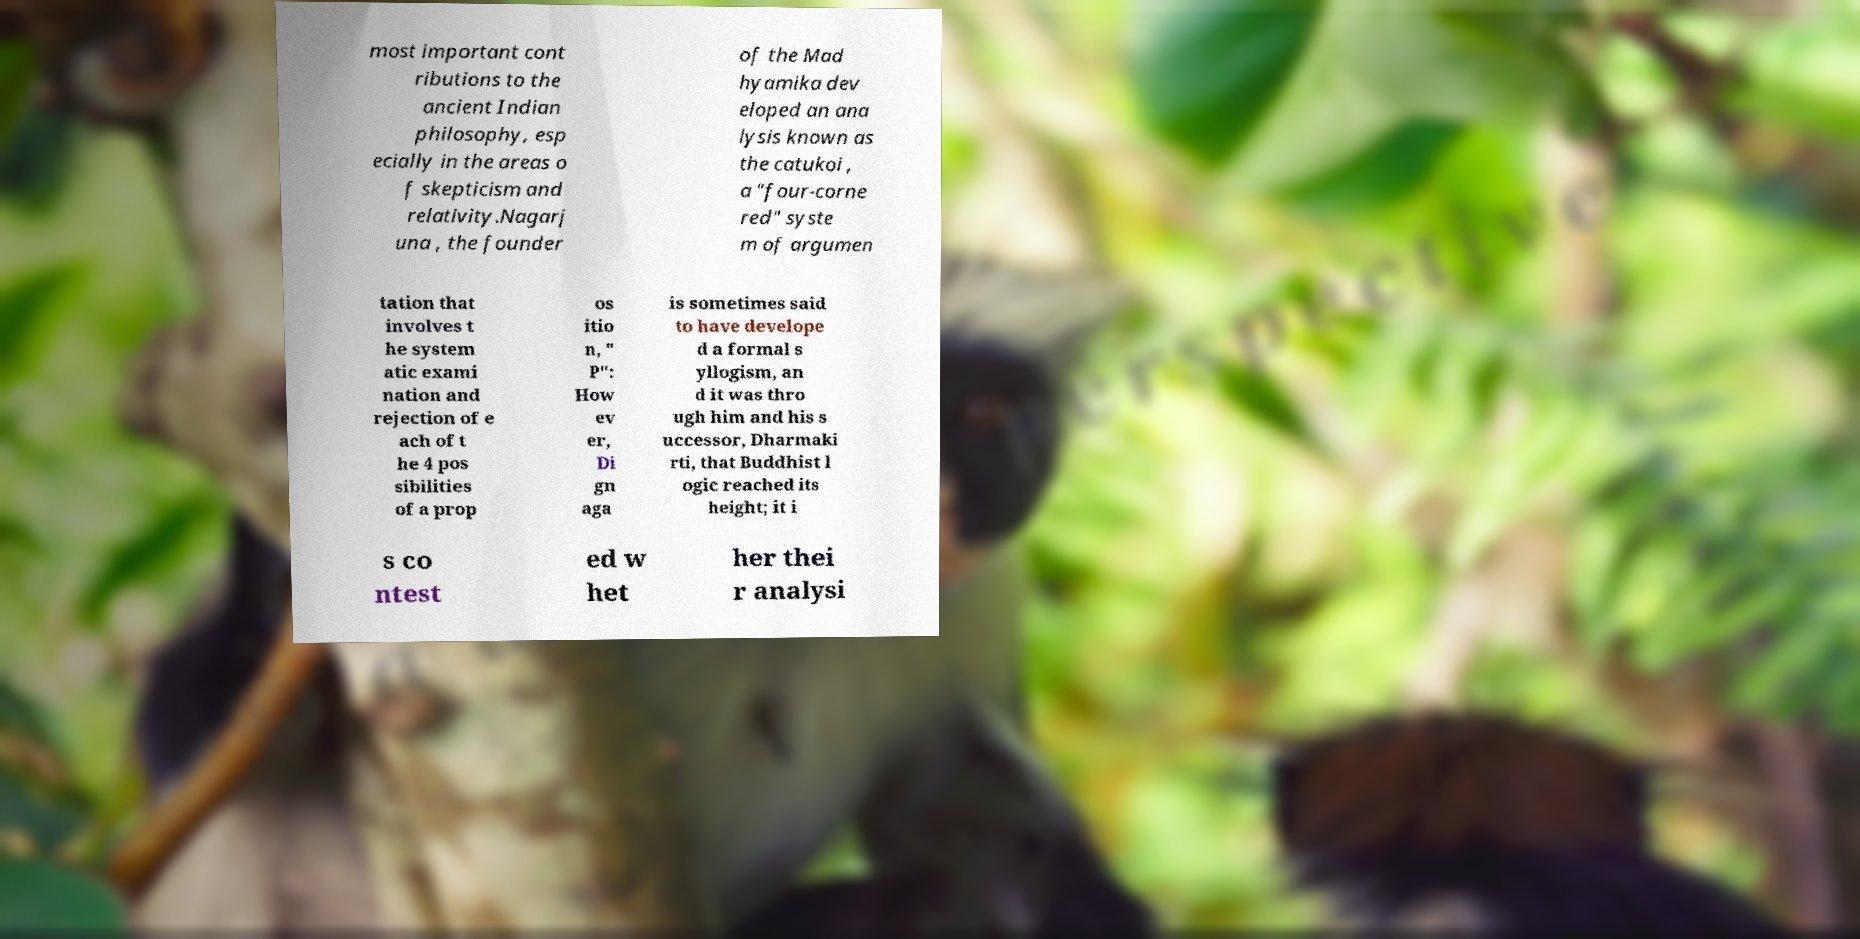Can you accurately transcribe the text from the provided image for me? most important cont ributions to the ancient Indian philosophy, esp ecially in the areas o f skepticism and relativity.Nagarj una , the founder of the Mad hyamika dev eloped an ana lysis known as the catukoi , a "four-corne red" syste m of argumen tation that involves t he system atic exami nation and rejection of e ach of t he 4 pos sibilities of a prop os itio n, " P": How ev er, Di gn aga is sometimes said to have develope d a formal s yllogism, an d it was thro ugh him and his s uccessor, Dharmaki rti, that Buddhist l ogic reached its height; it i s co ntest ed w het her thei r analysi 